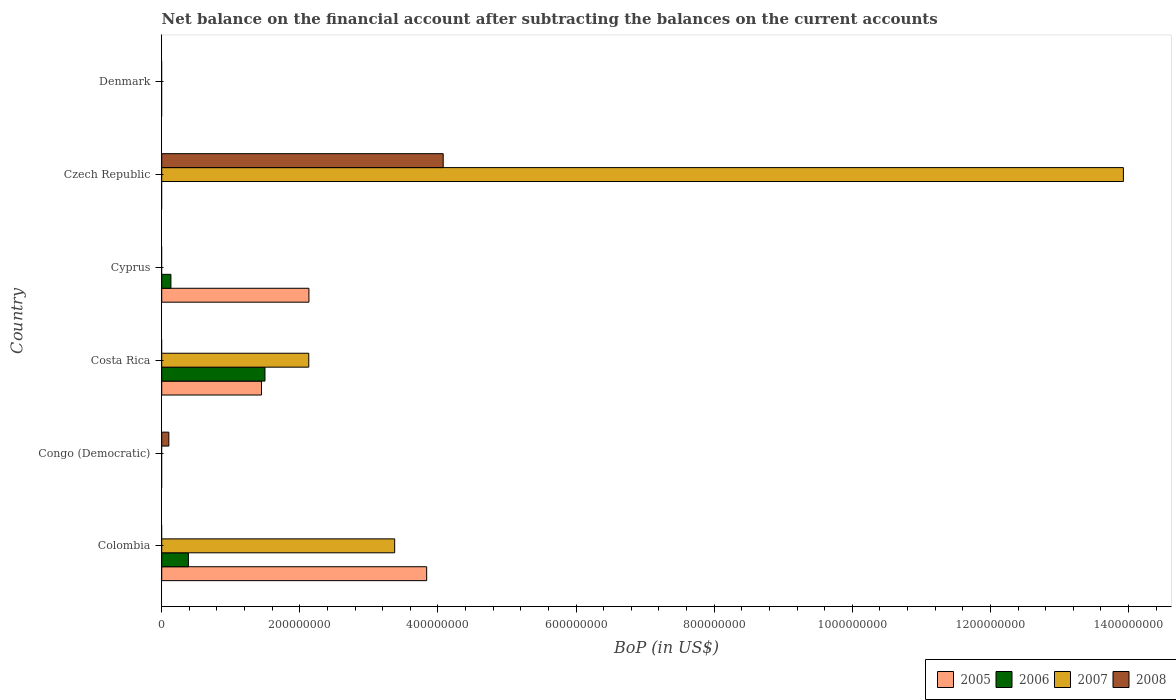How many different coloured bars are there?
Keep it short and to the point. 4. How many bars are there on the 2nd tick from the bottom?
Make the answer very short. 1. What is the label of the 5th group of bars from the top?
Your answer should be very brief. Congo (Democratic). What is the Balance of Payments in 2006 in Czech Republic?
Make the answer very short. 0. Across all countries, what is the maximum Balance of Payments in 2005?
Make the answer very short. 3.84e+08. Across all countries, what is the minimum Balance of Payments in 2007?
Your answer should be compact. 0. In which country was the Balance of Payments in 2006 maximum?
Provide a short and direct response. Costa Rica. What is the total Balance of Payments in 2006 in the graph?
Make the answer very short. 2.02e+08. What is the difference between the Balance of Payments in 2008 in Czech Republic and the Balance of Payments in 2005 in Costa Rica?
Provide a succinct answer. 2.63e+08. What is the average Balance of Payments in 2008 per country?
Your answer should be very brief. 6.96e+07. What is the difference between the Balance of Payments in 2007 and Balance of Payments in 2005 in Colombia?
Offer a very short reply. -4.63e+07. What is the ratio of the Balance of Payments in 2006 in Costa Rica to that in Cyprus?
Make the answer very short. 11.21. What is the difference between the highest and the second highest Balance of Payments in 2006?
Ensure brevity in your answer.  1.11e+08. What is the difference between the highest and the lowest Balance of Payments in 2006?
Your response must be concise. 1.50e+08. In how many countries, is the Balance of Payments in 2005 greater than the average Balance of Payments in 2005 taken over all countries?
Keep it short and to the point. 3. Is the sum of the Balance of Payments in 2006 in Colombia and Cyprus greater than the maximum Balance of Payments in 2008 across all countries?
Offer a terse response. No. Is it the case that in every country, the sum of the Balance of Payments in 2005 and Balance of Payments in 2008 is greater than the sum of Balance of Payments in 2006 and Balance of Payments in 2007?
Your response must be concise. No. Is it the case that in every country, the sum of the Balance of Payments in 2005 and Balance of Payments in 2008 is greater than the Balance of Payments in 2007?
Your response must be concise. No. How many bars are there?
Offer a very short reply. 11. How many countries are there in the graph?
Make the answer very short. 6. Are the values on the major ticks of X-axis written in scientific E-notation?
Your response must be concise. No. Does the graph contain any zero values?
Your response must be concise. Yes. Does the graph contain grids?
Your response must be concise. No. How are the legend labels stacked?
Ensure brevity in your answer.  Horizontal. What is the title of the graph?
Ensure brevity in your answer.  Net balance on the financial account after subtracting the balances on the current accounts. Does "1966" appear as one of the legend labels in the graph?
Make the answer very short. No. What is the label or title of the X-axis?
Ensure brevity in your answer.  BoP (in US$). What is the label or title of the Y-axis?
Your answer should be very brief. Country. What is the BoP (in US$) in 2005 in Colombia?
Keep it short and to the point. 3.84e+08. What is the BoP (in US$) in 2006 in Colombia?
Give a very brief answer. 3.87e+07. What is the BoP (in US$) of 2007 in Colombia?
Keep it short and to the point. 3.37e+08. What is the BoP (in US$) in 2008 in Colombia?
Provide a short and direct response. 0. What is the BoP (in US$) of 2005 in Congo (Democratic)?
Ensure brevity in your answer.  0. What is the BoP (in US$) of 2006 in Congo (Democratic)?
Your response must be concise. 0. What is the BoP (in US$) in 2008 in Congo (Democratic)?
Your response must be concise. 1.03e+07. What is the BoP (in US$) in 2005 in Costa Rica?
Provide a short and direct response. 1.44e+08. What is the BoP (in US$) in 2006 in Costa Rica?
Offer a terse response. 1.50e+08. What is the BoP (in US$) in 2007 in Costa Rica?
Make the answer very short. 2.13e+08. What is the BoP (in US$) in 2005 in Cyprus?
Your response must be concise. 2.13e+08. What is the BoP (in US$) in 2006 in Cyprus?
Provide a short and direct response. 1.33e+07. What is the BoP (in US$) of 2008 in Cyprus?
Your answer should be compact. 0. What is the BoP (in US$) in 2005 in Czech Republic?
Offer a terse response. 0. What is the BoP (in US$) in 2007 in Czech Republic?
Ensure brevity in your answer.  1.39e+09. What is the BoP (in US$) in 2008 in Czech Republic?
Your answer should be compact. 4.08e+08. What is the BoP (in US$) of 2005 in Denmark?
Provide a short and direct response. 0. What is the BoP (in US$) of 2007 in Denmark?
Provide a short and direct response. 0. Across all countries, what is the maximum BoP (in US$) of 2005?
Give a very brief answer. 3.84e+08. Across all countries, what is the maximum BoP (in US$) in 2006?
Provide a succinct answer. 1.50e+08. Across all countries, what is the maximum BoP (in US$) of 2007?
Offer a terse response. 1.39e+09. Across all countries, what is the maximum BoP (in US$) in 2008?
Your answer should be very brief. 4.08e+08. Across all countries, what is the minimum BoP (in US$) in 2005?
Your answer should be very brief. 0. Across all countries, what is the minimum BoP (in US$) in 2006?
Provide a succinct answer. 0. Across all countries, what is the minimum BoP (in US$) in 2008?
Offer a very short reply. 0. What is the total BoP (in US$) of 2005 in the graph?
Ensure brevity in your answer.  7.41e+08. What is the total BoP (in US$) of 2006 in the graph?
Provide a short and direct response. 2.02e+08. What is the total BoP (in US$) of 2007 in the graph?
Offer a terse response. 1.94e+09. What is the total BoP (in US$) in 2008 in the graph?
Your answer should be very brief. 4.18e+08. What is the difference between the BoP (in US$) of 2005 in Colombia and that in Costa Rica?
Make the answer very short. 2.39e+08. What is the difference between the BoP (in US$) in 2006 in Colombia and that in Costa Rica?
Your answer should be very brief. -1.11e+08. What is the difference between the BoP (in US$) in 2007 in Colombia and that in Costa Rica?
Provide a short and direct response. 1.24e+08. What is the difference between the BoP (in US$) in 2005 in Colombia and that in Cyprus?
Provide a succinct answer. 1.70e+08. What is the difference between the BoP (in US$) of 2006 in Colombia and that in Cyprus?
Your answer should be compact. 2.53e+07. What is the difference between the BoP (in US$) of 2007 in Colombia and that in Czech Republic?
Ensure brevity in your answer.  -1.06e+09. What is the difference between the BoP (in US$) in 2008 in Congo (Democratic) and that in Czech Republic?
Your answer should be compact. -3.97e+08. What is the difference between the BoP (in US$) in 2005 in Costa Rica and that in Cyprus?
Your response must be concise. -6.87e+07. What is the difference between the BoP (in US$) in 2006 in Costa Rica and that in Cyprus?
Ensure brevity in your answer.  1.36e+08. What is the difference between the BoP (in US$) of 2007 in Costa Rica and that in Czech Republic?
Provide a short and direct response. -1.18e+09. What is the difference between the BoP (in US$) of 2005 in Colombia and the BoP (in US$) of 2008 in Congo (Democratic)?
Your answer should be compact. 3.73e+08. What is the difference between the BoP (in US$) in 2006 in Colombia and the BoP (in US$) in 2008 in Congo (Democratic)?
Your answer should be very brief. 2.84e+07. What is the difference between the BoP (in US$) of 2007 in Colombia and the BoP (in US$) of 2008 in Congo (Democratic)?
Your answer should be compact. 3.27e+08. What is the difference between the BoP (in US$) in 2005 in Colombia and the BoP (in US$) in 2006 in Costa Rica?
Give a very brief answer. 2.34e+08. What is the difference between the BoP (in US$) in 2005 in Colombia and the BoP (in US$) in 2007 in Costa Rica?
Keep it short and to the point. 1.71e+08. What is the difference between the BoP (in US$) in 2006 in Colombia and the BoP (in US$) in 2007 in Costa Rica?
Give a very brief answer. -1.74e+08. What is the difference between the BoP (in US$) of 2005 in Colombia and the BoP (in US$) of 2006 in Cyprus?
Offer a very short reply. 3.70e+08. What is the difference between the BoP (in US$) in 2005 in Colombia and the BoP (in US$) in 2007 in Czech Republic?
Ensure brevity in your answer.  -1.01e+09. What is the difference between the BoP (in US$) of 2005 in Colombia and the BoP (in US$) of 2008 in Czech Republic?
Your answer should be compact. -2.39e+07. What is the difference between the BoP (in US$) of 2006 in Colombia and the BoP (in US$) of 2007 in Czech Republic?
Offer a terse response. -1.35e+09. What is the difference between the BoP (in US$) in 2006 in Colombia and the BoP (in US$) in 2008 in Czech Republic?
Make the answer very short. -3.69e+08. What is the difference between the BoP (in US$) in 2007 in Colombia and the BoP (in US$) in 2008 in Czech Republic?
Keep it short and to the point. -7.03e+07. What is the difference between the BoP (in US$) in 2005 in Costa Rica and the BoP (in US$) in 2006 in Cyprus?
Your response must be concise. 1.31e+08. What is the difference between the BoP (in US$) of 2005 in Costa Rica and the BoP (in US$) of 2007 in Czech Republic?
Offer a very short reply. -1.25e+09. What is the difference between the BoP (in US$) of 2005 in Costa Rica and the BoP (in US$) of 2008 in Czech Republic?
Your answer should be very brief. -2.63e+08. What is the difference between the BoP (in US$) in 2006 in Costa Rica and the BoP (in US$) in 2007 in Czech Republic?
Provide a succinct answer. -1.24e+09. What is the difference between the BoP (in US$) of 2006 in Costa Rica and the BoP (in US$) of 2008 in Czech Republic?
Keep it short and to the point. -2.58e+08. What is the difference between the BoP (in US$) in 2007 in Costa Rica and the BoP (in US$) in 2008 in Czech Republic?
Offer a very short reply. -1.95e+08. What is the difference between the BoP (in US$) of 2005 in Cyprus and the BoP (in US$) of 2007 in Czech Republic?
Your answer should be compact. -1.18e+09. What is the difference between the BoP (in US$) of 2005 in Cyprus and the BoP (in US$) of 2008 in Czech Republic?
Ensure brevity in your answer.  -1.94e+08. What is the difference between the BoP (in US$) of 2006 in Cyprus and the BoP (in US$) of 2007 in Czech Republic?
Offer a very short reply. -1.38e+09. What is the difference between the BoP (in US$) of 2006 in Cyprus and the BoP (in US$) of 2008 in Czech Republic?
Offer a terse response. -3.94e+08. What is the average BoP (in US$) of 2005 per country?
Offer a terse response. 1.24e+08. What is the average BoP (in US$) of 2006 per country?
Offer a terse response. 3.36e+07. What is the average BoP (in US$) of 2007 per country?
Your answer should be compact. 3.24e+08. What is the average BoP (in US$) in 2008 per country?
Offer a very short reply. 6.96e+07. What is the difference between the BoP (in US$) in 2005 and BoP (in US$) in 2006 in Colombia?
Keep it short and to the point. 3.45e+08. What is the difference between the BoP (in US$) in 2005 and BoP (in US$) in 2007 in Colombia?
Your answer should be very brief. 4.63e+07. What is the difference between the BoP (in US$) in 2006 and BoP (in US$) in 2007 in Colombia?
Your response must be concise. -2.99e+08. What is the difference between the BoP (in US$) in 2005 and BoP (in US$) in 2006 in Costa Rica?
Keep it short and to the point. -5.05e+06. What is the difference between the BoP (in US$) of 2005 and BoP (in US$) of 2007 in Costa Rica?
Offer a terse response. -6.85e+07. What is the difference between the BoP (in US$) of 2006 and BoP (in US$) of 2007 in Costa Rica?
Your response must be concise. -6.34e+07. What is the difference between the BoP (in US$) in 2005 and BoP (in US$) in 2006 in Cyprus?
Your answer should be compact. 2.00e+08. What is the difference between the BoP (in US$) in 2007 and BoP (in US$) in 2008 in Czech Republic?
Your response must be concise. 9.85e+08. What is the ratio of the BoP (in US$) of 2005 in Colombia to that in Costa Rica?
Keep it short and to the point. 2.66. What is the ratio of the BoP (in US$) of 2006 in Colombia to that in Costa Rica?
Your answer should be compact. 0.26. What is the ratio of the BoP (in US$) of 2007 in Colombia to that in Costa Rica?
Keep it short and to the point. 1.58. What is the ratio of the BoP (in US$) in 2005 in Colombia to that in Cyprus?
Give a very brief answer. 1.8. What is the ratio of the BoP (in US$) of 2006 in Colombia to that in Cyprus?
Your answer should be very brief. 2.9. What is the ratio of the BoP (in US$) in 2007 in Colombia to that in Czech Republic?
Ensure brevity in your answer.  0.24. What is the ratio of the BoP (in US$) of 2008 in Congo (Democratic) to that in Czech Republic?
Give a very brief answer. 0.03. What is the ratio of the BoP (in US$) of 2005 in Costa Rica to that in Cyprus?
Provide a succinct answer. 0.68. What is the ratio of the BoP (in US$) of 2006 in Costa Rica to that in Cyprus?
Your response must be concise. 11.21. What is the ratio of the BoP (in US$) of 2007 in Costa Rica to that in Czech Republic?
Your answer should be compact. 0.15. What is the difference between the highest and the second highest BoP (in US$) of 2005?
Make the answer very short. 1.70e+08. What is the difference between the highest and the second highest BoP (in US$) of 2006?
Ensure brevity in your answer.  1.11e+08. What is the difference between the highest and the second highest BoP (in US$) of 2007?
Offer a terse response. 1.06e+09. What is the difference between the highest and the lowest BoP (in US$) of 2005?
Ensure brevity in your answer.  3.84e+08. What is the difference between the highest and the lowest BoP (in US$) in 2006?
Your response must be concise. 1.50e+08. What is the difference between the highest and the lowest BoP (in US$) of 2007?
Make the answer very short. 1.39e+09. What is the difference between the highest and the lowest BoP (in US$) in 2008?
Your response must be concise. 4.08e+08. 